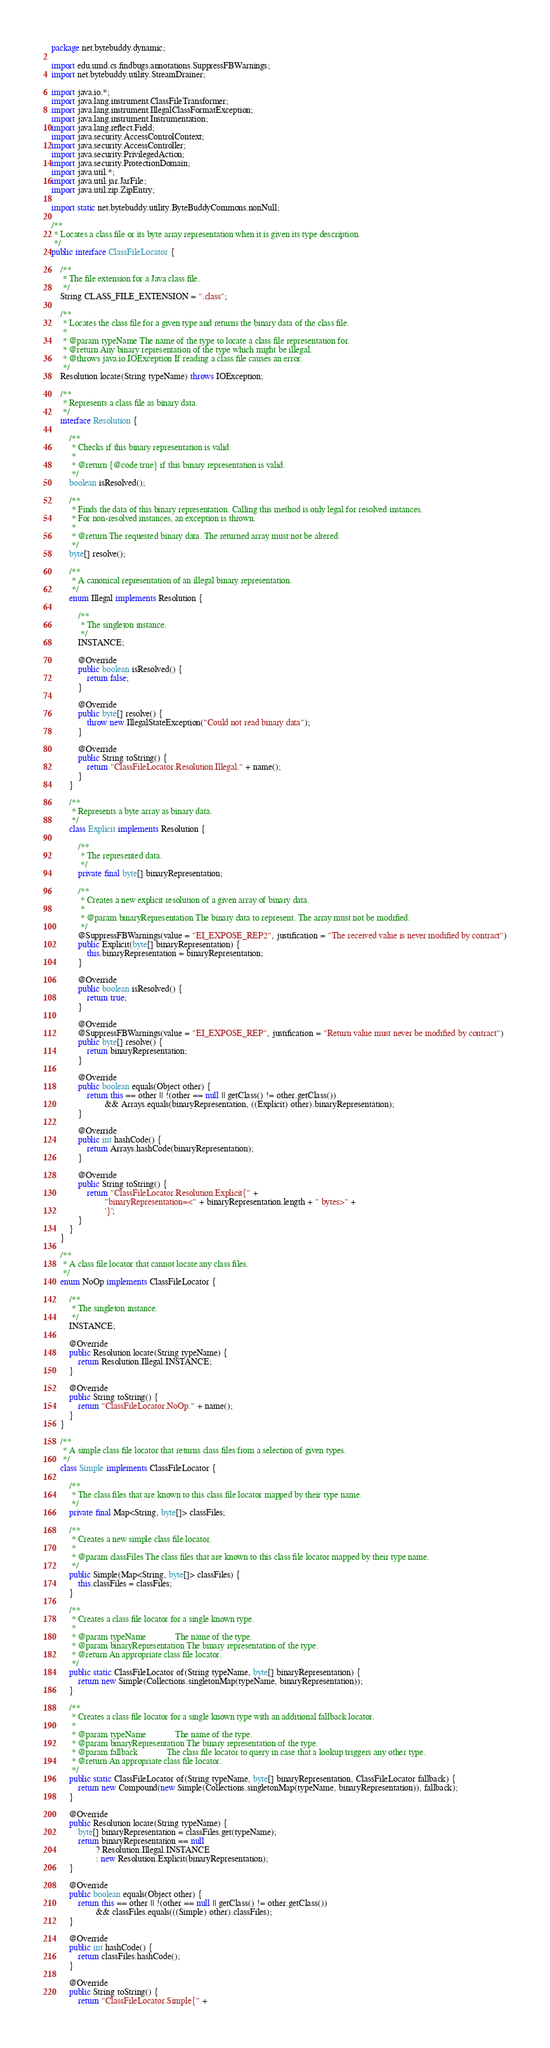Convert code to text. <code><loc_0><loc_0><loc_500><loc_500><_Java_>package net.bytebuddy.dynamic;

import edu.umd.cs.findbugs.annotations.SuppressFBWarnings;
import net.bytebuddy.utility.StreamDrainer;

import java.io.*;
import java.lang.instrument.ClassFileTransformer;
import java.lang.instrument.IllegalClassFormatException;
import java.lang.instrument.Instrumentation;
import java.lang.reflect.Field;
import java.security.AccessControlContext;
import java.security.AccessController;
import java.security.PrivilegedAction;
import java.security.ProtectionDomain;
import java.util.*;
import java.util.jar.JarFile;
import java.util.zip.ZipEntry;

import static net.bytebuddy.utility.ByteBuddyCommons.nonNull;

/**
 * Locates a class file or its byte array representation when it is given its type description.
 */
public interface ClassFileLocator {

    /**
     * The file extension for a Java class file.
     */
    String CLASS_FILE_EXTENSION = ".class";

    /**
     * Locates the class file for a given type and returns the binary data of the class file.
     *
     * @param typeName The name of the type to locate a class file representation for.
     * @return Any binary representation of the type which might be illegal.
     * @throws java.io.IOException If reading a class file causes an error.
     */
    Resolution locate(String typeName) throws IOException;

    /**
     * Represents a class file as binary data.
     */
    interface Resolution {

        /**
         * Checks if this binary representation is valid.
         *
         * @return {@code true} if this binary representation is valid.
         */
        boolean isResolved();

        /**
         * Finds the data of this binary representation. Calling this method is only legal for resolved instances.
         * For non-resolved instances, an exception is thrown.
         *
         * @return The requested binary data. The returned array must not be altered.
         */
        byte[] resolve();

        /**
         * A canonical representation of an illegal binary representation.
         */
        enum Illegal implements Resolution {

            /**
             * The singleton instance.
             */
            INSTANCE;

            @Override
            public boolean isResolved() {
                return false;
            }

            @Override
            public byte[] resolve() {
                throw new IllegalStateException("Could not read binary data");
            }

            @Override
            public String toString() {
                return "ClassFileLocator.Resolution.Illegal." + name();
            }
        }

        /**
         * Represents a byte array as binary data.
         */
        class Explicit implements Resolution {

            /**
             * The represented data.
             */
            private final byte[] binaryRepresentation;

            /**
             * Creates a new explicit resolution of a given array of binary data.
             *
             * @param binaryRepresentation The binary data to represent. The array must not be modified.
             */
            @SuppressFBWarnings(value = "EI_EXPOSE_REP2", justification = "The received value is never modified by contract")
            public Explicit(byte[] binaryRepresentation) {
                this.binaryRepresentation = binaryRepresentation;
            }

            @Override
            public boolean isResolved() {
                return true;
            }

            @Override
            @SuppressFBWarnings(value = "EI_EXPOSE_REP", justification = "Return value must never be modified by contract")
            public byte[] resolve() {
                return binaryRepresentation;
            }

            @Override
            public boolean equals(Object other) {
                return this == other || !(other == null || getClass() != other.getClass())
                        && Arrays.equals(binaryRepresentation, ((Explicit) other).binaryRepresentation);
            }

            @Override
            public int hashCode() {
                return Arrays.hashCode(binaryRepresentation);
            }

            @Override
            public String toString() {
                return "ClassFileLocator.Resolution.Explicit{" +
                        "binaryRepresentation=<" + binaryRepresentation.length + " bytes>" +
                        '}';
            }
        }
    }

    /**
     * A class file locator that cannot locate any class files.
     */
    enum NoOp implements ClassFileLocator {

        /**
         * The singleton instance.
         */
        INSTANCE;

        @Override
        public Resolution locate(String typeName) {
            return Resolution.Illegal.INSTANCE;
        }

        @Override
        public String toString() {
            return "ClassFileLocator.NoOp." + name();
        }
    }

    /**
     * A simple class file locator that returns class files from a selection of given types.
     */
    class Simple implements ClassFileLocator {

        /**
         * The class files that are known to this class file locator mapped by their type name.
         */
        private final Map<String, byte[]> classFiles;

        /**
         * Creates a new simple class file locator.
         *
         * @param classFiles The class files that are known to this class file locator mapped by their type name.
         */
        public Simple(Map<String, byte[]> classFiles) {
            this.classFiles = classFiles;
        }

        /**
         * Creates a class file locator for a single known type.
         *
         * @param typeName             The name of the type.
         * @param binaryRepresentation The binary representation of the type.
         * @return An appropriate class file locator.
         */
        public static ClassFileLocator of(String typeName, byte[] binaryRepresentation) {
            return new Simple(Collections.singletonMap(typeName, binaryRepresentation));
        }

        /**
         * Creates a class file locator for a single known type with an additional fallback locator.
         *
         * @param typeName             The name of the type.
         * @param binaryRepresentation The binary representation of the type.
         * @param fallback             The class file locator to query in case that a lookup triggers any other type.
         * @return An appropriate class file locator.
         */
        public static ClassFileLocator of(String typeName, byte[] binaryRepresentation, ClassFileLocator fallback) {
            return new Compound(new Simple(Collections.singletonMap(typeName, binaryRepresentation)), fallback);
        }

        @Override
        public Resolution locate(String typeName) {
            byte[] binaryRepresentation = classFiles.get(typeName);
            return binaryRepresentation == null
                    ? Resolution.Illegal.INSTANCE
                    : new Resolution.Explicit(binaryRepresentation);
        }

        @Override
        public boolean equals(Object other) {
            return this == other || !(other == null || getClass() != other.getClass())
                    && classFiles.equals(((Simple) other).classFiles);
        }

        @Override
        public int hashCode() {
            return classFiles.hashCode();
        }

        @Override
        public String toString() {
            return "ClassFileLocator.Simple{" +</code> 